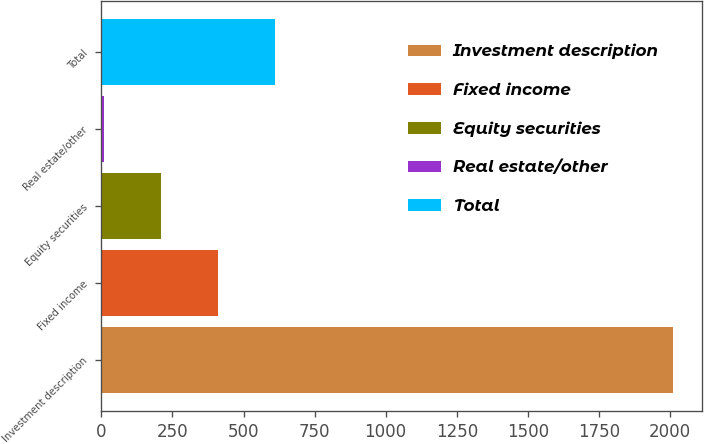Convert chart to OTSL. <chart><loc_0><loc_0><loc_500><loc_500><bar_chart><fcel>Investment description<fcel>Fixed income<fcel>Equity securities<fcel>Real estate/other<fcel>Total<nl><fcel>2012<fcel>411.2<fcel>211.1<fcel>11<fcel>611.3<nl></chart> 